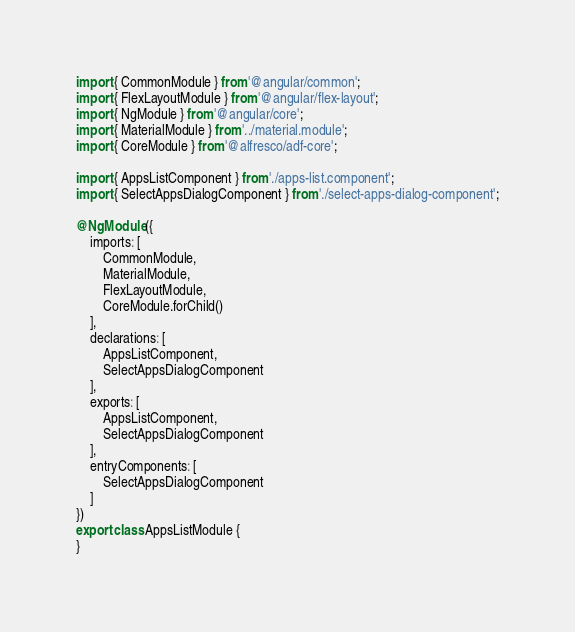Convert code to text. <code><loc_0><loc_0><loc_500><loc_500><_TypeScript_>
import { CommonModule } from '@angular/common';
import { FlexLayoutModule } from '@angular/flex-layout';
import { NgModule } from '@angular/core';
import { MaterialModule } from '../material.module';
import { CoreModule } from '@alfresco/adf-core';

import { AppsListComponent } from './apps-list.component';
import { SelectAppsDialogComponent } from './select-apps-dialog-component';

@NgModule({
    imports: [
        CommonModule,
        MaterialModule,
        FlexLayoutModule,
        CoreModule.forChild()
    ],
    declarations: [
        AppsListComponent,
        SelectAppsDialogComponent
    ],
    exports: [
        AppsListComponent,
        SelectAppsDialogComponent
    ],
    entryComponents: [
        SelectAppsDialogComponent
    ]
})
export class AppsListModule {
}
</code> 